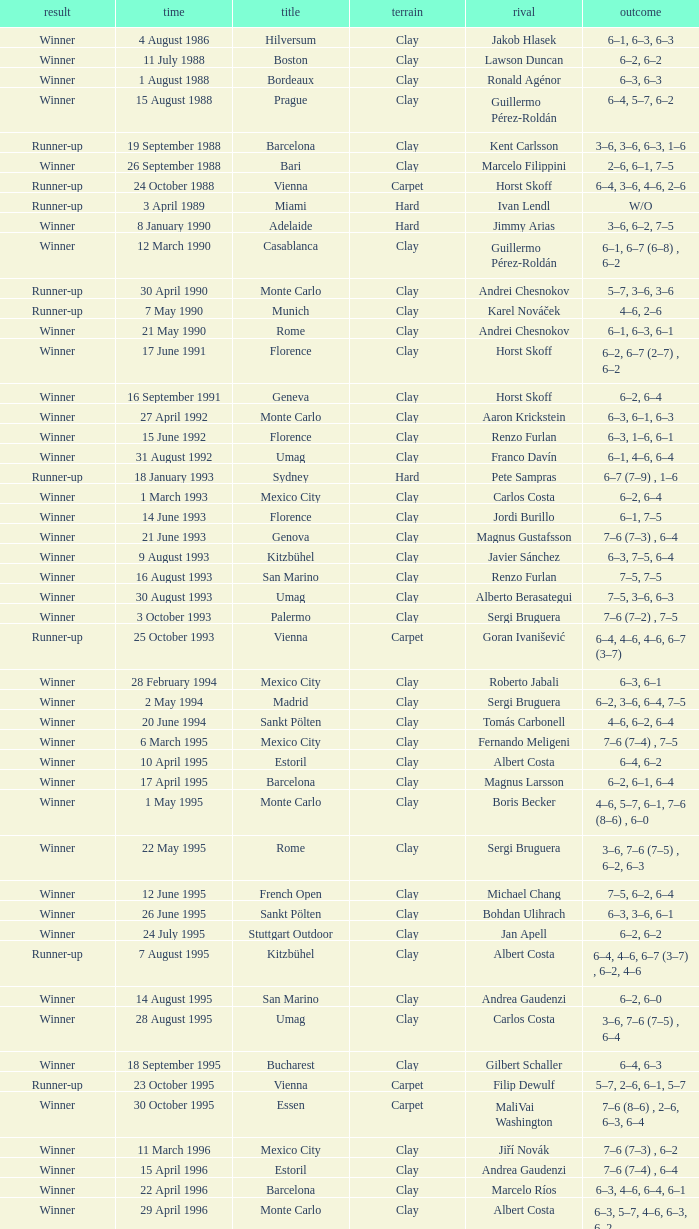What is the surface on 21 june 1993? Clay. 